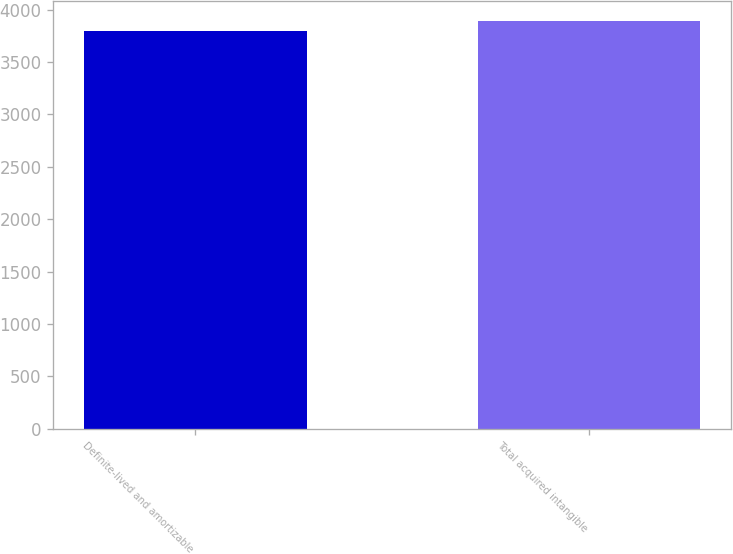Convert chart. <chart><loc_0><loc_0><loc_500><loc_500><bar_chart><fcel>Definite-lived and amortizable<fcel>Total acquired intangible<nl><fcel>3793<fcel>3893<nl></chart> 